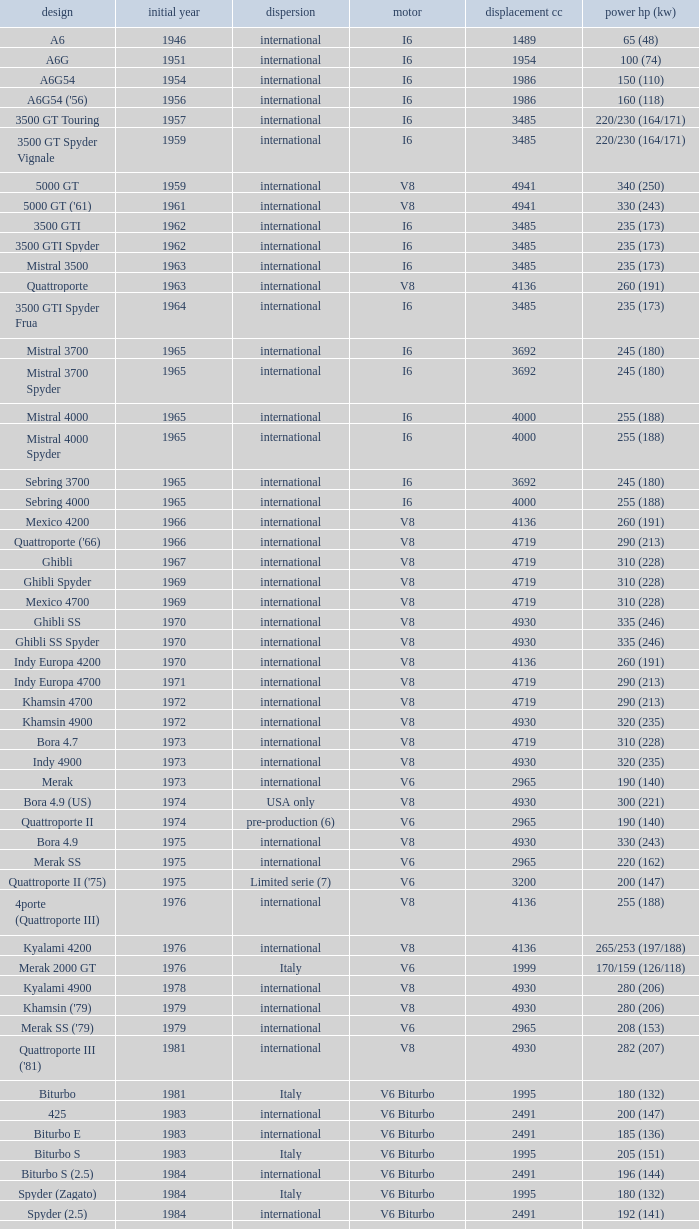What is the lowest First Year, when Model is "Quattroporte (2.8)"? 1994.0. Can you parse all the data within this table? {'header': ['design', 'initial year', 'dispersion', 'motor', 'displacement cc', 'power hp (kw)'], 'rows': [['A6', '1946', 'international', 'I6', '1489', '65 (48)'], ['A6G', '1951', 'international', 'I6', '1954', '100 (74)'], ['A6G54', '1954', 'international', 'I6', '1986', '150 (110)'], ["A6G54 ('56)", '1956', 'international', 'I6', '1986', '160 (118)'], ['3500 GT Touring', '1957', 'international', 'I6', '3485', '220/230 (164/171)'], ['3500 GT Spyder Vignale', '1959', 'international', 'I6', '3485', '220/230 (164/171)'], ['5000 GT', '1959', 'international', 'V8', '4941', '340 (250)'], ["5000 GT ('61)", '1961', 'international', 'V8', '4941', '330 (243)'], ['3500 GTI', '1962', 'international', 'I6', '3485', '235 (173)'], ['3500 GTI Spyder', '1962', 'international', 'I6', '3485', '235 (173)'], ['Mistral 3500', '1963', 'international', 'I6', '3485', '235 (173)'], ['Quattroporte', '1963', 'international', 'V8', '4136', '260 (191)'], ['3500 GTI Spyder Frua', '1964', 'international', 'I6', '3485', '235 (173)'], ['Mistral 3700', '1965', 'international', 'I6', '3692', '245 (180)'], ['Mistral 3700 Spyder', '1965', 'international', 'I6', '3692', '245 (180)'], ['Mistral 4000', '1965', 'international', 'I6', '4000', '255 (188)'], ['Mistral 4000 Spyder', '1965', 'international', 'I6', '4000', '255 (188)'], ['Sebring 3700', '1965', 'international', 'I6', '3692', '245 (180)'], ['Sebring 4000', '1965', 'international', 'I6', '4000', '255 (188)'], ['Mexico 4200', '1966', 'international', 'V8', '4136', '260 (191)'], ["Quattroporte ('66)", '1966', 'international', 'V8', '4719', '290 (213)'], ['Ghibli', '1967', 'international', 'V8', '4719', '310 (228)'], ['Ghibli Spyder', '1969', 'international', 'V8', '4719', '310 (228)'], ['Mexico 4700', '1969', 'international', 'V8', '4719', '310 (228)'], ['Ghibli SS', '1970', 'international', 'V8', '4930', '335 (246)'], ['Ghibli SS Spyder', '1970', 'international', 'V8', '4930', '335 (246)'], ['Indy Europa 4200', '1970', 'international', 'V8', '4136', '260 (191)'], ['Indy Europa 4700', '1971', 'international', 'V8', '4719', '290 (213)'], ['Khamsin 4700', '1972', 'international', 'V8', '4719', '290 (213)'], ['Khamsin 4900', '1972', 'international', 'V8', '4930', '320 (235)'], ['Bora 4.7', '1973', 'international', 'V8', '4719', '310 (228)'], ['Indy 4900', '1973', 'international', 'V8', '4930', '320 (235)'], ['Merak', '1973', 'international', 'V6', '2965', '190 (140)'], ['Bora 4.9 (US)', '1974', 'USA only', 'V8', '4930', '300 (221)'], ['Quattroporte II', '1974', 'pre-production (6)', 'V6', '2965', '190 (140)'], ['Bora 4.9', '1975', 'international', 'V8', '4930', '330 (243)'], ['Merak SS', '1975', 'international', 'V6', '2965', '220 (162)'], ["Quattroporte II ('75)", '1975', 'Limited serie (7)', 'V6', '3200', '200 (147)'], ['4porte (Quattroporte III)', '1976', 'international', 'V8', '4136', '255 (188)'], ['Kyalami 4200', '1976', 'international', 'V8', '4136', '265/253 (197/188)'], ['Merak 2000 GT', '1976', 'Italy', 'V6', '1999', '170/159 (126/118)'], ['Kyalami 4900', '1978', 'international', 'V8', '4930', '280 (206)'], ["Khamsin ('79)", '1979', 'international', 'V8', '4930', '280 (206)'], ["Merak SS ('79)", '1979', 'international', 'V6', '2965', '208 (153)'], ["Quattroporte III ('81)", '1981', 'international', 'V8', '4930', '282 (207)'], ['Biturbo', '1981', 'Italy', 'V6 Biturbo', '1995', '180 (132)'], ['425', '1983', 'international', 'V6 Biturbo', '2491', '200 (147)'], ['Biturbo E', '1983', 'international', 'V6 Biturbo', '2491', '185 (136)'], ['Biturbo S', '1983', 'Italy', 'V6 Biturbo', '1995', '205 (151)'], ['Biturbo S (2.5)', '1984', 'international', 'V6 Biturbo', '2491', '196 (144)'], ['Spyder (Zagato)', '1984', 'Italy', 'V6 Biturbo', '1995', '180 (132)'], ['Spyder (2.5)', '1984', 'international', 'V6 Biturbo', '2491', '192 (141)'], ['420', '1985', 'Italy', 'V6 Biturbo', '1995', '180 (132)'], ['Biturbo (II)', '1985', 'Italy', 'V6 Biturbo', '1995', '180 (132)'], ['Biturbo E (II 2.5)', '1985', 'international', 'V6 Biturbo', '2491', '185 (136)'], ['Biturbo S (II)', '1985', 'Italy', 'V6 Biturbo', '1995', '210 (154)'], ['228 (228i)', '1986', 'international', 'V6 Biturbo', '2790', '250 (184)'], ['228 (228i) Kat', '1986', 'international', 'V6 Biturbo', '2790', '225 (165)'], ['420i', '1986', 'Italy', 'V6 Biturbo', '1995', '190 (140)'], ['420 S', '1986', 'Italy', 'V6 Biturbo', '1995', '210 (154)'], ['Biturbo i', '1986', 'Italy', 'V6 Biturbo', '1995', '185 (136)'], ['Quattroporte Royale (III)', '1986', 'international', 'V8', '4930', '300 (221)'], ['Spyder i', '1986', 'international', 'V6 Biturbo', '1996', '185 (136)'], ['430', '1987', 'international', 'V6 Biturbo', '2790', '225 (165)'], ['425i', '1987', 'international', 'V6 Biturbo', '2491', '188 (138)'], ['Biturbo Si', '1987', 'Italy', 'V6 Biturbo', '1995', '220 (162)'], ['Biturbo Si (2.5)', '1987', 'international', 'V6 Biturbo', '2491', '188 (138)'], ["Spyder i ('87)", '1987', 'international', 'V6 Biturbo', '1996', '195 (143)'], ['222', '1988', 'Italy', 'V6 Biturbo', '1996', '220 (162)'], ['422', '1988', 'Italy', 'V6 Biturbo', '1996', '220 (162)'], ['2.24V', '1988', 'Italy (probably)', 'V6 Biturbo', '1996', '245 (180)'], ['222 4v', '1988', 'international', 'V6 Biturbo', '2790', '279 (205)'], ['222 E', '1988', 'international', 'V6 Biturbo', '2790', '225 (165)'], ['Karif', '1988', 'international', 'V6 Biturbo', '2790', '285 (210)'], ['Karif (kat)', '1988', 'international', 'V6 Biturbo', '2790', '248 (182)'], ['Karif (kat II)', '1988', 'international', 'V6 Biturbo', '2790', '225 (165)'], ['Spyder i (2.5)', '1988', 'international', 'V6 Biturbo', '2491', '188 (138)'], ['Spyder i (2.8)', '1989', 'international', 'V6 Biturbo', '2790', '250 (184)'], ['Spyder i (2.8, kat)', '1989', 'international', 'V6 Biturbo', '2790', '225 (165)'], ["Spyder i ('90)", '1989', 'Italy', 'V6 Biturbo', '1996', '220 (162)'], ['222 SE', '1990', 'international', 'V6 Biturbo', '2790', '250 (184)'], ['222 SE (kat)', '1990', 'international', 'V6 Biturbo', '2790', '225 (165)'], ['4.18v', '1990', 'Italy', 'V6 Biturbo', '1995', '220 (162)'], ['4.24v', '1990', 'Italy (probably)', 'V6 Biturbo', '1996', '245 (180)'], ['Shamal', '1990', 'international', 'V8 Biturbo', '3217', '326 (240)'], ['2.24v II', '1991', 'Italy', 'V6 Biturbo', '1996', '245 (180)'], ['2.24v II (kat)', '1991', 'international (probably)', 'V6 Biturbo', '1996', '240 (176)'], ['222 SR', '1991', 'international', 'V6 Biturbo', '2790', '225 (165)'], ['4.24v II (kat)', '1991', 'Italy (probably)', 'V6 Biturbo', '1996', '240 (176)'], ['430 4v', '1991', 'international', 'V6 Biturbo', '2790', '279 (205)'], ['Racing', '1991', 'Italy', 'V6 Biturbo', '1996', '283 (208)'], ['Spyder III', '1991', 'Italy', 'V6 Biturbo', '1996', '245 (180)'], ['Spyder III (2.8, kat)', '1991', 'international', 'V6 Biturbo', '2790', '225 (165)'], ['Spyder III (kat)', '1991', 'Italy', 'V6 Biturbo', '1996', '240 (176)'], ['Barchetta Stradale', '1992', 'Prototype', 'V6 Biturbo', '1996', '306 (225)'], ['Barchetta Stradale 2.8', '1992', 'Single, Conversion', 'V6 Biturbo', '2790', '284 (209)'], ['Ghibli II (2.0)', '1992', 'Italy', 'V6 Biturbo', '1996', '306 (225)'], ['Ghibli II (2.8)', '1993', 'international', 'V6 Biturbo', '2790', '284 (209)'], ['Quattroporte (2.0)', '1994', 'Italy', 'V6 Biturbo', '1996', '287 (211)'], ['Quattroporte (2.8)', '1994', 'international', 'V6 Biturbo', '2790', '284 (209)'], ['Ghibli Cup', '1995', 'international', 'V6 Biturbo', '1996', '330 (243)'], ['Quattroporte Ottocilindri', '1995', 'international', 'V8 Biturbo', '3217', '335 (246)'], ['Ghibli Primatist', '1996', 'international', 'V6 Biturbo', '1996', '306 (225)'], ['3200 GT', '1998', 'international', 'V8 Biturbo', '3217', '370 (272)'], ['Quattroporte V6 Evoluzione', '1998', 'international', 'V6 Biturbo', '2790', '284 (209)'], ['Quattroporte V8 Evoluzione', '1998', 'international', 'V8 Biturbo', '3217', '335 (246)'], ['3200 GTA', '2000', 'international', 'V8 Biturbo', '3217', '368 (271)'], ['Spyder GT', '2001', 'international', 'V8', '4244', '390 (287)'], ['Spyder CC', '2001', 'international', 'V8', '4244', '390 (287)'], ['Coupé GT', '2001', 'international', 'V8', '4244', '390 (287)'], ['Coupé CC', '2001', 'international', 'V8', '4244', '390 (287)'], ['Gran Sport', '2002', 'international', 'V8', '4244', '400 (294)'], ['Quattroporte V', '2004', 'international', 'V8', '4244', '400 (294)'], ['MC12 (aka MCC)', '2004', 'Limited', 'V12', '5998', '630 (463)'], ['GranTurismo', '2008', 'international', 'V8', '4244', '405'], ['GranCabrio', '2010', 'international', 'V8', '4691', '433']]} 